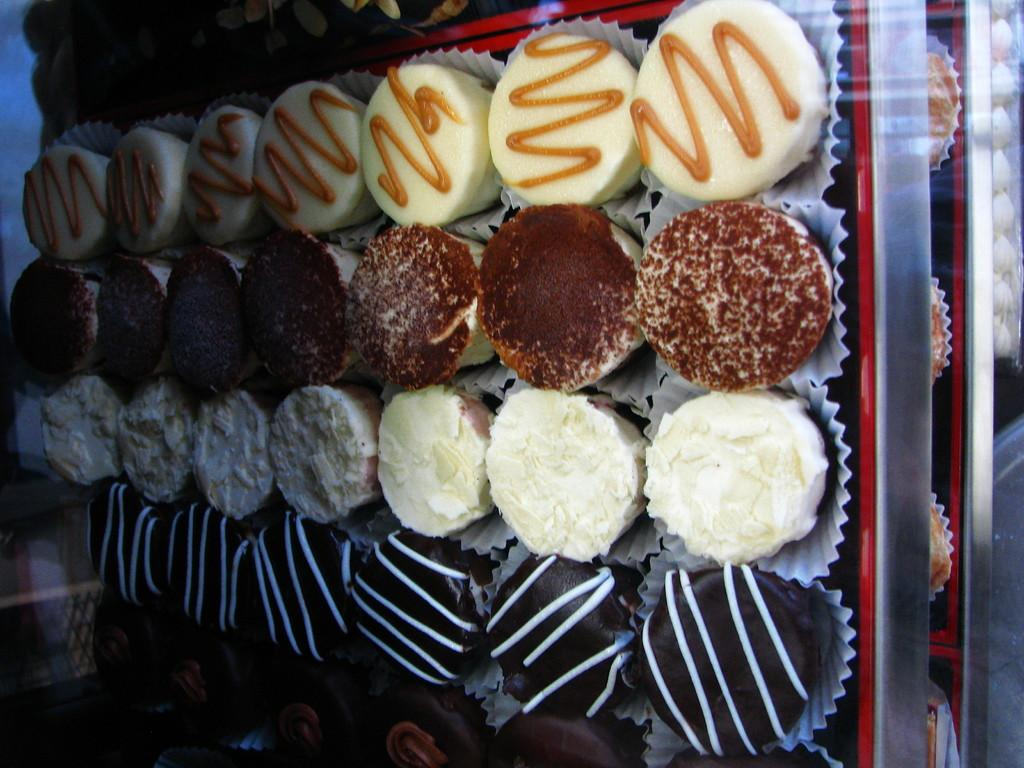What type of food can be seen in the image? There are muffins in the image. How are the muffins arranged or organized? The muffins are in trays. What type of bread can be seen in the image? There is no bread present in the image; it features muffins in trays. How many cows are visible in the image? There are no cows present in the image. 